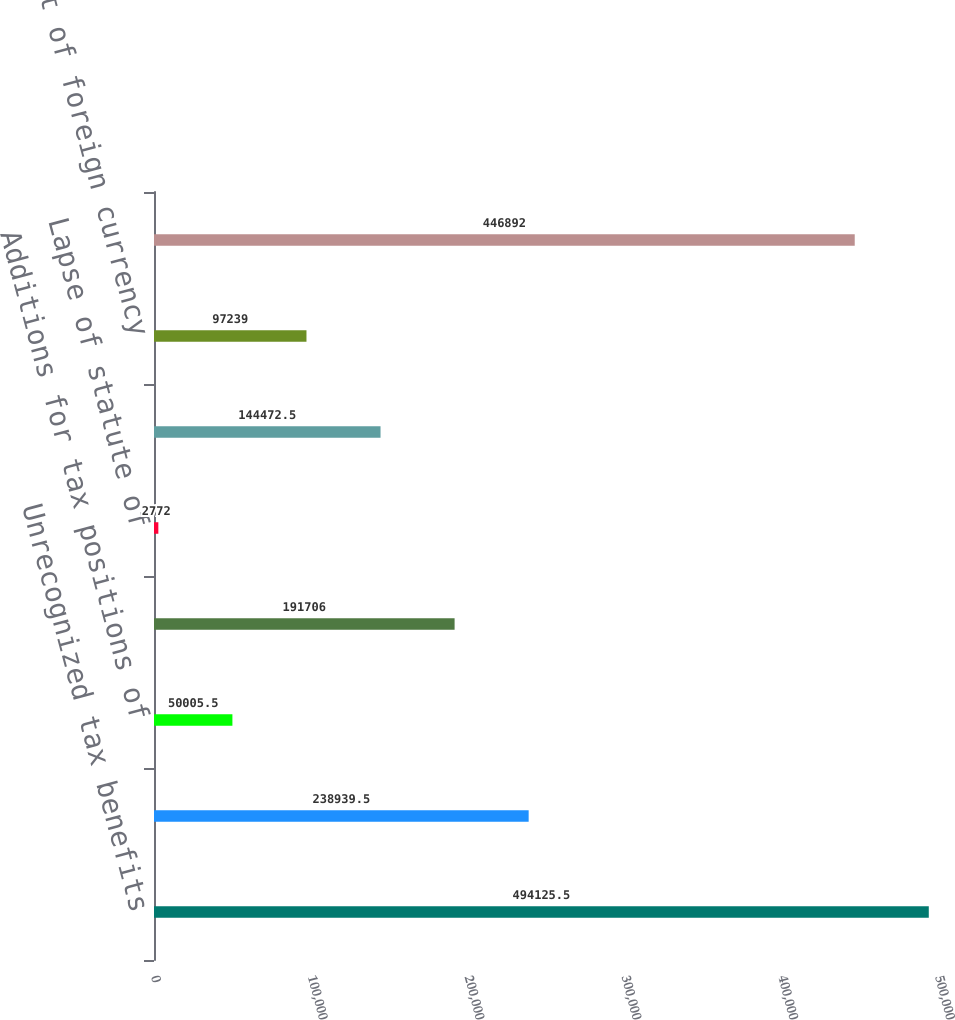<chart> <loc_0><loc_0><loc_500><loc_500><bar_chart><fcel>Unrecognized tax benefits<fcel>Additions based on tax<fcel>Additions for tax positions of<fcel>Reductions for tax position of<fcel>Lapse of statute of<fcel>Settlements<fcel>Effect of foreign currency<fcel>Unrecognized tax benefits end<nl><fcel>494126<fcel>238940<fcel>50005.5<fcel>191706<fcel>2772<fcel>144472<fcel>97239<fcel>446892<nl></chart> 